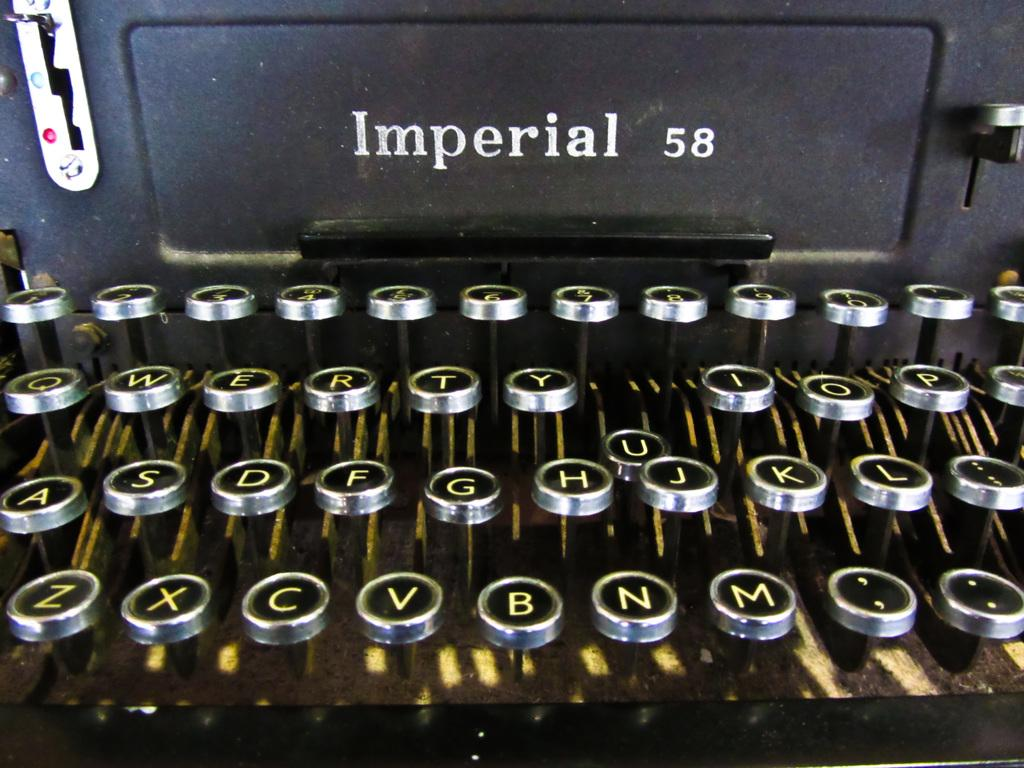Provide a one-sentence caption for the provided image. An old fashioned Imperial 58 typewriter with round keys. 